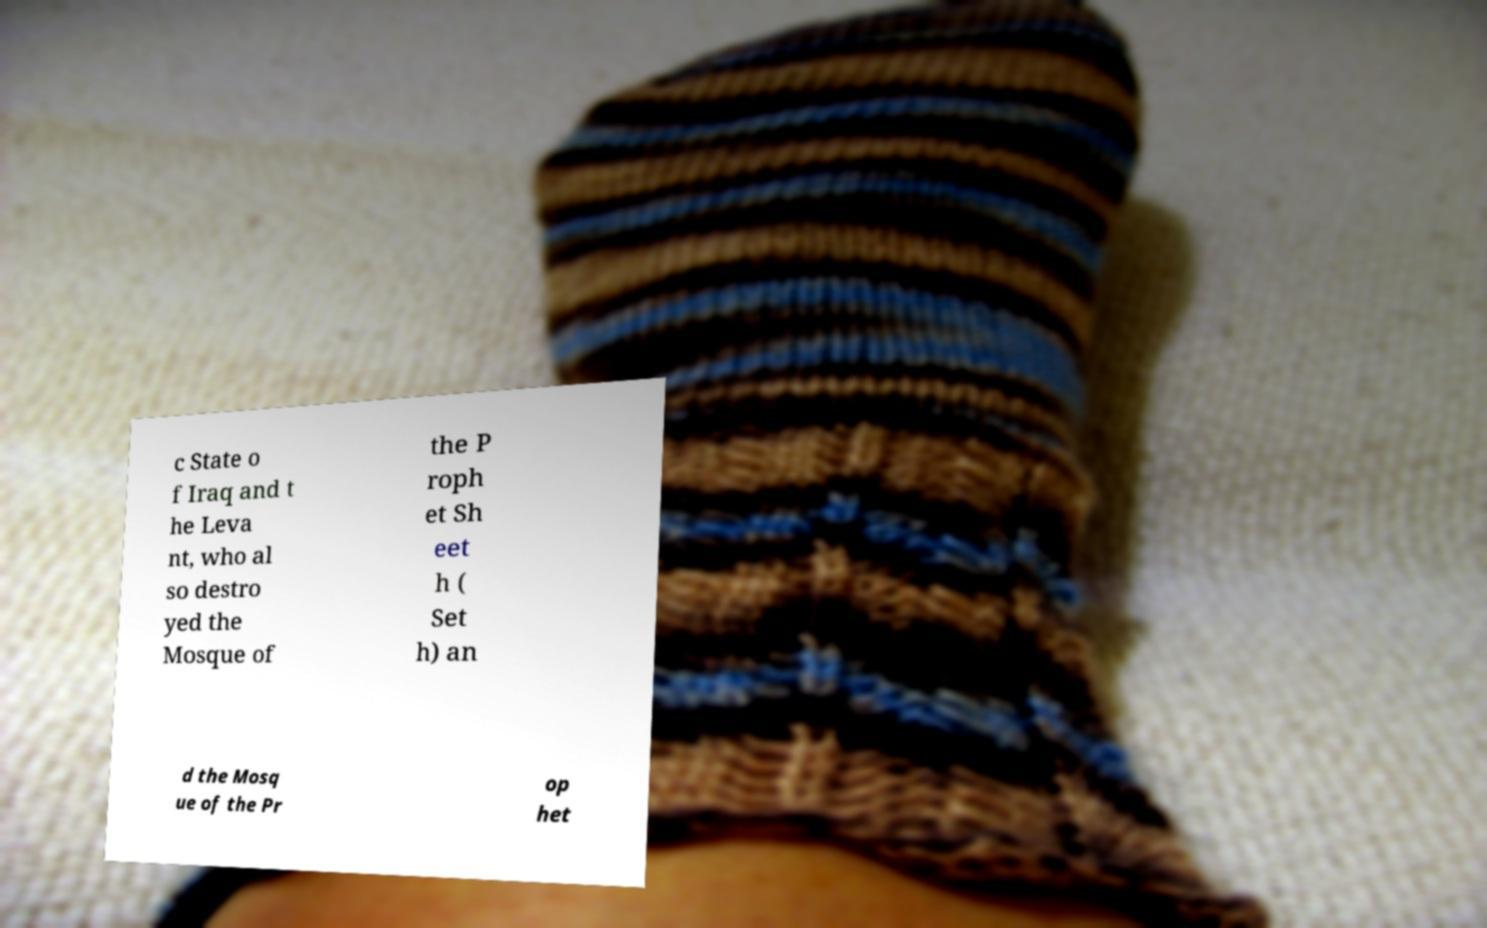Can you read and provide the text displayed in the image?This photo seems to have some interesting text. Can you extract and type it out for me? c State o f Iraq and t he Leva nt, who al so destro yed the Mosque of the P roph et Sh eet h ( Set h) an d the Mosq ue of the Pr op het 